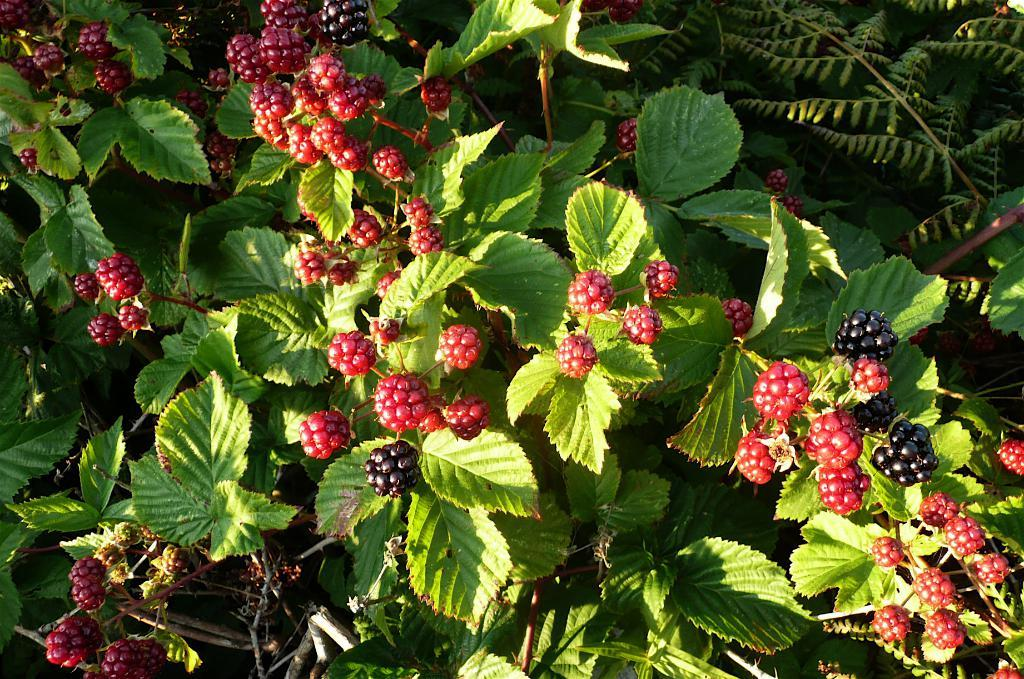What type of living organisms can be seen on the plant in the image? There are fruits on the plant in the image. Can you describe the fruits on the plant? Unfortunately, the specific type of fruits cannot be determined from the image alone. What is the natural setting of the image? The image features a plant with fruits, which suggests a natural setting. What type of lock can be seen securing the fruits on the plant in the image? There is no lock present in the image; the fruits are on a plant in a natural setting. 